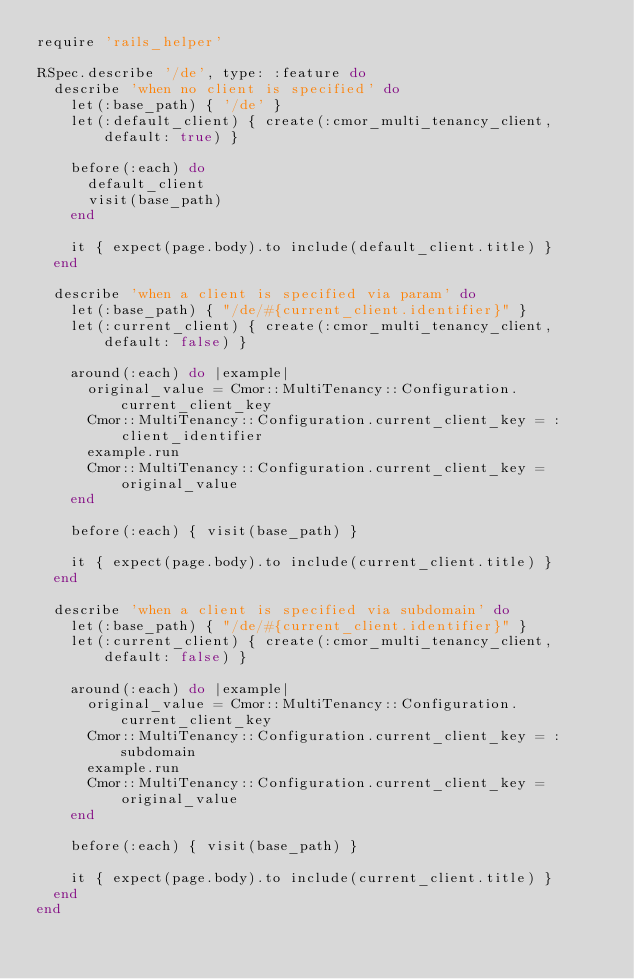<code> <loc_0><loc_0><loc_500><loc_500><_Ruby_>require 'rails_helper'

RSpec.describe '/de', type: :feature do
  describe 'when no client is specified' do
    let(:base_path) { '/de' }
    let(:default_client) { create(:cmor_multi_tenancy_client, default: true) }

    before(:each) do
      default_client
      visit(base_path)
    end

    it { expect(page.body).to include(default_client.title) }
  end

  describe 'when a client is specified via param' do
    let(:base_path) { "/de/#{current_client.identifier}" }
    let(:current_client) { create(:cmor_multi_tenancy_client, default: false) }

    around(:each) do |example|
      original_value = Cmor::MultiTenancy::Configuration.current_client_key
      Cmor::MultiTenancy::Configuration.current_client_key = :client_identifier
      example.run
      Cmor::MultiTenancy::Configuration.current_client_key = original_value
    end

    before(:each) { visit(base_path) }

    it { expect(page.body).to include(current_client.title) }
  end

  describe 'when a client is specified via subdomain' do
    let(:base_path) { "/de/#{current_client.identifier}" }
    let(:current_client) { create(:cmor_multi_tenancy_client, default: false) }

    around(:each) do |example|
      original_value = Cmor::MultiTenancy::Configuration.current_client_key
      Cmor::MultiTenancy::Configuration.current_client_key = :subdomain
      example.run
      Cmor::MultiTenancy::Configuration.current_client_key = original_value
    end

    before(:each) { visit(base_path) }

    it { expect(page.body).to include(current_client.title) }
  end
end</code> 